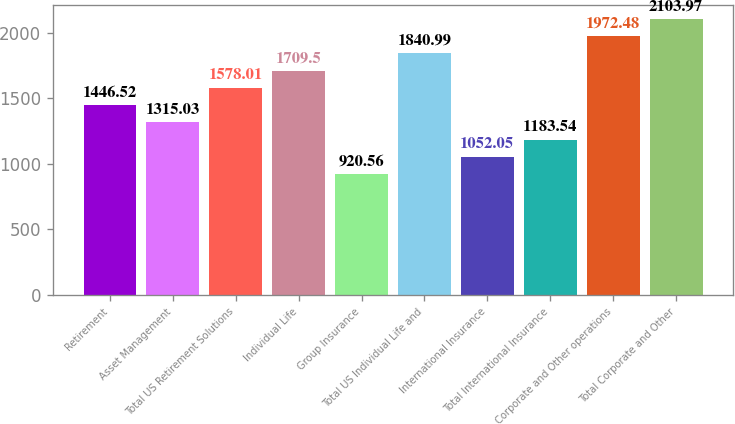Convert chart to OTSL. <chart><loc_0><loc_0><loc_500><loc_500><bar_chart><fcel>Retirement<fcel>Asset Management<fcel>Total US Retirement Solutions<fcel>Individual Life<fcel>Group Insurance<fcel>Total US Individual Life and<fcel>International Insurance<fcel>Total International Insurance<fcel>Corporate and Other operations<fcel>Total Corporate and Other<nl><fcel>1446.52<fcel>1315.03<fcel>1578.01<fcel>1709.5<fcel>920.56<fcel>1840.99<fcel>1052.05<fcel>1183.54<fcel>1972.48<fcel>2103.97<nl></chart> 